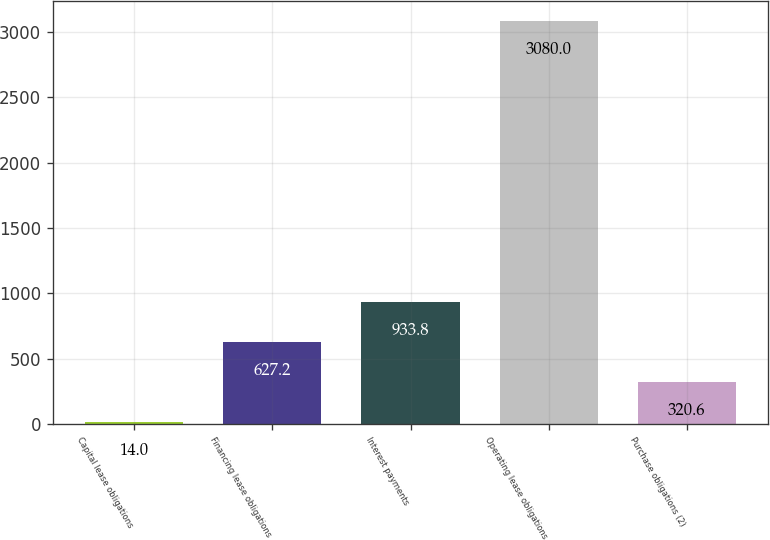Convert chart to OTSL. <chart><loc_0><loc_0><loc_500><loc_500><bar_chart><fcel>Capital lease obligations<fcel>Financing lease obligations<fcel>Interest payments<fcel>Operating lease obligations<fcel>Purchase obligations (2)<nl><fcel>14<fcel>627.2<fcel>933.8<fcel>3080<fcel>320.6<nl></chart> 